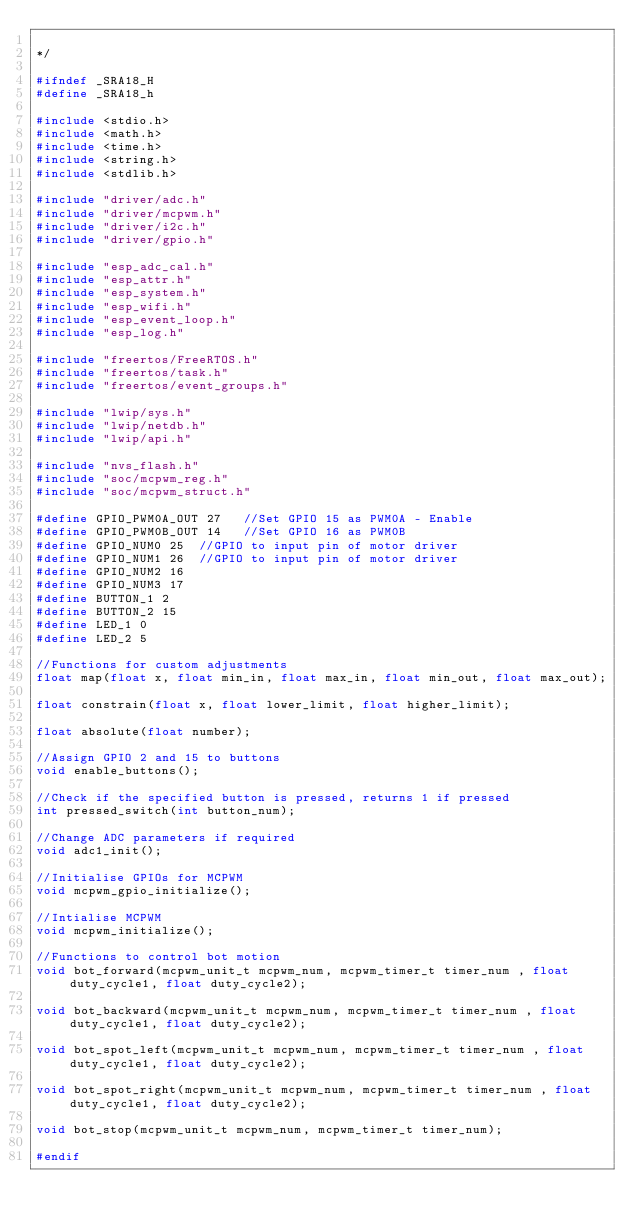<code> <loc_0><loc_0><loc_500><loc_500><_C_>
*/

#ifndef _SRA18_H
#define _SRA18_h

#include <stdio.h>
#include <math.h>
#include <time.h>
#include <string.h>
#include <stdlib.h>

#include "driver/adc.h"
#include "driver/mcpwm.h"
#include "driver/i2c.h"
#include "driver/gpio.h"

#include "esp_adc_cal.h"
#include "esp_attr.h"
#include "esp_system.h"
#include "esp_wifi.h"
#include "esp_event_loop.h"
#include "esp_log.h"

#include "freertos/FreeRTOS.h"
#include "freertos/task.h"
#include "freertos/event_groups.h"

#include "lwip/sys.h"
#include "lwip/netdb.h"
#include "lwip/api.h"

#include "nvs_flash.h"
#include "soc/mcpwm_reg.h"
#include "soc/mcpwm_struct.h"

#define GPIO_PWM0A_OUT 27   //Set GPIO 15 as PWM0A - Enable
#define GPIO_PWM0B_OUT 14   //Set GPIO 16 as PWM0B 
#define GPIO_NUM0 25  //GPIO to input pin of motor driver
#define GPIO_NUM1 26  //GPIO to input pin of motor driver
#define GPIO_NUM2 16
#define GPIO_NUM3 17
#define BUTTON_1 2
#define BUTTON_2 15
#define LED_1 0
#define LED_2 5

//Functions for custom adjustments
float map(float x, float min_in, float max_in, float min_out, float max_out);

float constrain(float x, float lower_limit, float higher_limit);

float absolute(float number);

//Assign GPIO 2 and 15 to buttons
void enable_buttons();

//Check if the specified button is pressed, returns 1 if pressed
int pressed_switch(int button_num);

//Change ADC parameters if required 
void adc1_init();

//Initialise GPIOs for MCPWM
void mcpwm_gpio_initialize();

//Intialise MCPWM 
void mcpwm_initialize();

//Functions to control bot motion
void bot_forward(mcpwm_unit_t mcpwm_num, mcpwm_timer_t timer_num , float duty_cycle1, float duty_cycle2);

void bot_backward(mcpwm_unit_t mcpwm_num, mcpwm_timer_t timer_num , float duty_cycle1, float duty_cycle2);

void bot_spot_left(mcpwm_unit_t mcpwm_num, mcpwm_timer_t timer_num , float duty_cycle1, float duty_cycle2);

void bot_spot_right(mcpwm_unit_t mcpwm_num, mcpwm_timer_t timer_num , float duty_cycle1, float duty_cycle2);

void bot_stop(mcpwm_unit_t mcpwm_num, mcpwm_timer_t timer_num);

#endif
</code> 